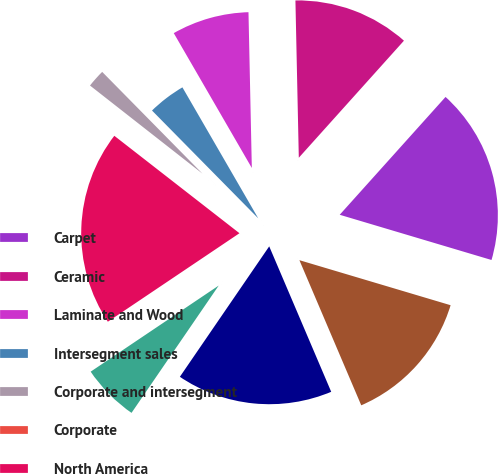Convert chart. <chart><loc_0><loc_0><loc_500><loc_500><pie_chart><fcel>Carpet<fcel>Ceramic<fcel>Laminate and Wood<fcel>Intersegment sales<fcel>Corporate and intersegment<fcel>Corporate<fcel>North America<fcel>Rest of world<fcel>Soft surface<fcel>Tile<nl><fcel>17.96%<fcel>11.99%<fcel>8.01%<fcel>4.03%<fcel>2.04%<fcel>0.05%<fcel>19.95%<fcel>6.02%<fcel>15.97%<fcel>13.98%<nl></chart> 